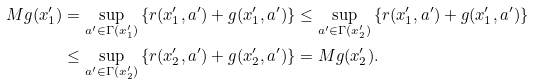<formula> <loc_0><loc_0><loc_500><loc_500>M g ( x _ { 1 } ^ { \prime } ) & = \sup _ { a ^ { \prime } \in \Gamma ( x _ { 1 } ^ { \prime } ) } \left \{ r ( x _ { 1 } ^ { \prime } , a ^ { \prime } ) + g ( x _ { 1 } ^ { \prime } , a ^ { \prime } ) \right \} \leq \sup _ { a ^ { \prime } \in \Gamma ( x _ { 2 } ^ { \prime } ) } \left \{ r ( x _ { 1 } ^ { \prime } , a ^ { \prime } ) + g ( x _ { 1 } ^ { \prime } , a ^ { \prime } ) \right \} \\ & \leq \sup _ { a ^ { \prime } \in \Gamma ( x _ { 2 } ^ { \prime } ) } \left \{ r ( x _ { 2 } ^ { \prime } , a ^ { \prime } ) + g ( x _ { 2 } ^ { \prime } , a ^ { \prime } ) \right \} = M g ( x _ { 2 } ^ { \prime } ) .</formula> 